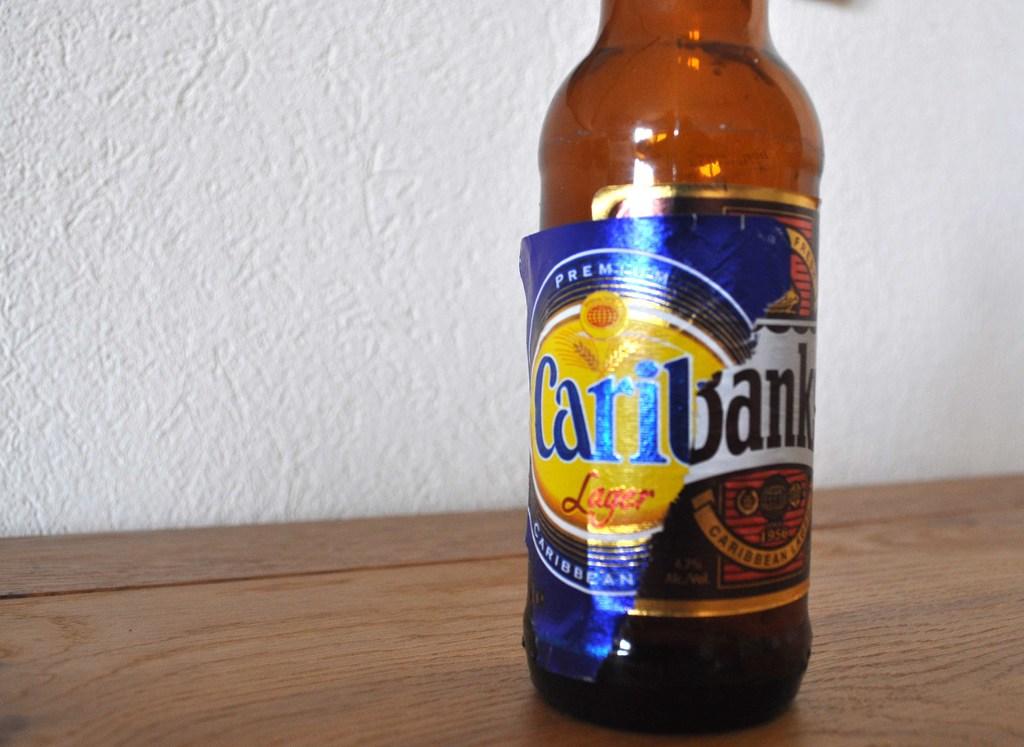What type of beer is this?
Your answer should be very brief. Caribank. What is the name of the beer in the bottle?
Provide a succinct answer. Caribank. 